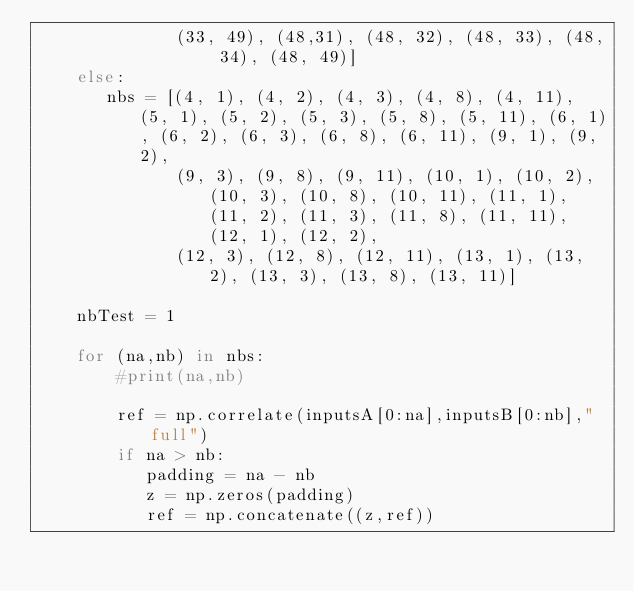Convert code to text. <code><loc_0><loc_0><loc_500><loc_500><_Python_>              (33, 49), (48,31), (48, 32), (48, 33), (48, 34), (48, 49)]
    else:
       nbs = [(4, 1), (4, 2), (4, 3), (4, 8), (4, 11), (5, 1), (5, 2), (5, 3), (5, 8), (5, 11), (6, 1), (6, 2), (6, 3), (6, 8), (6, 11), (9, 1), (9, 2), 
              (9, 3), (9, 8), (9, 11), (10, 1), (10, 2), (10, 3), (10, 8), (10, 11), (11, 1), (11, 2), (11, 3), (11, 8), (11, 11), (12, 1), (12, 2), 
              (12, 3), (12, 8), (12, 11), (13, 1), (13, 2), (13, 3), (13, 8), (13, 11)]

    nbTest = 1

    for (na,nb) in nbs:
        #print(na,nb)

        ref = np.correlate(inputsA[0:na],inputsB[0:nb],"full")
        if na > nb:
           padding = na - nb
           z = np.zeros(padding)
           ref = np.concatenate((z,ref))</code> 